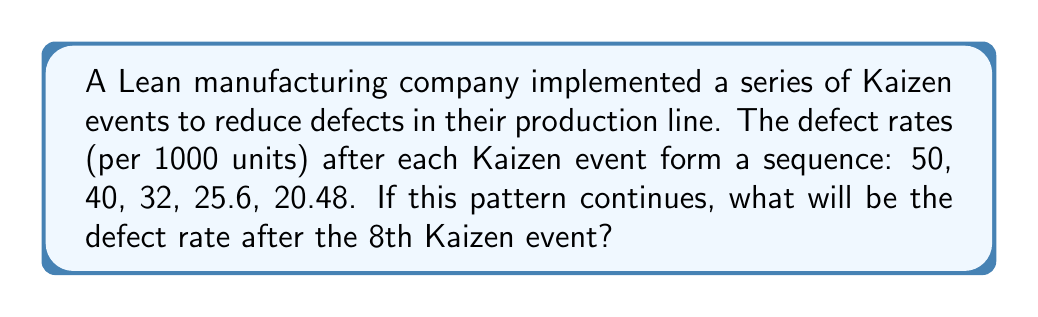Could you help me with this problem? To solve this problem, we need to identify the pattern in the defect reduction rates:

1. Calculate the ratio between consecutive terms:
   $\frac{40}{50} = 0.8$
   $\frac{32}{40} = 0.8$
   $\frac{25.6}{32} = 0.8$
   $\frac{20.48}{25.6} = 0.8$

2. We can see that each term is 0.8 times the previous term. This is a geometric sequence with a common ratio of 0.8.

3. The general term of a geometric sequence is given by:
   $a_n = a_1 \cdot r^{n-1}$
   Where $a_n$ is the nth term, $a_1$ is the first term, and $r$ is the common ratio.

4. In this case:
   $a_1 = 50$ (first term)
   $r = 0.8$ (common ratio)

5. We want to find the 8th term, so $n = 8$:
   $a_8 = 50 \cdot (0.8)^{8-1}$
   $a_8 = 50 \cdot (0.8)^7$

6. Calculate the result:
   $a_8 = 50 \cdot 0.2097152 = 10.48576$

Therefore, the defect rate after the 8th Kaizen event will be approximately 10.49 per 1000 units.
Answer: 10.49 defects per 1000 units 